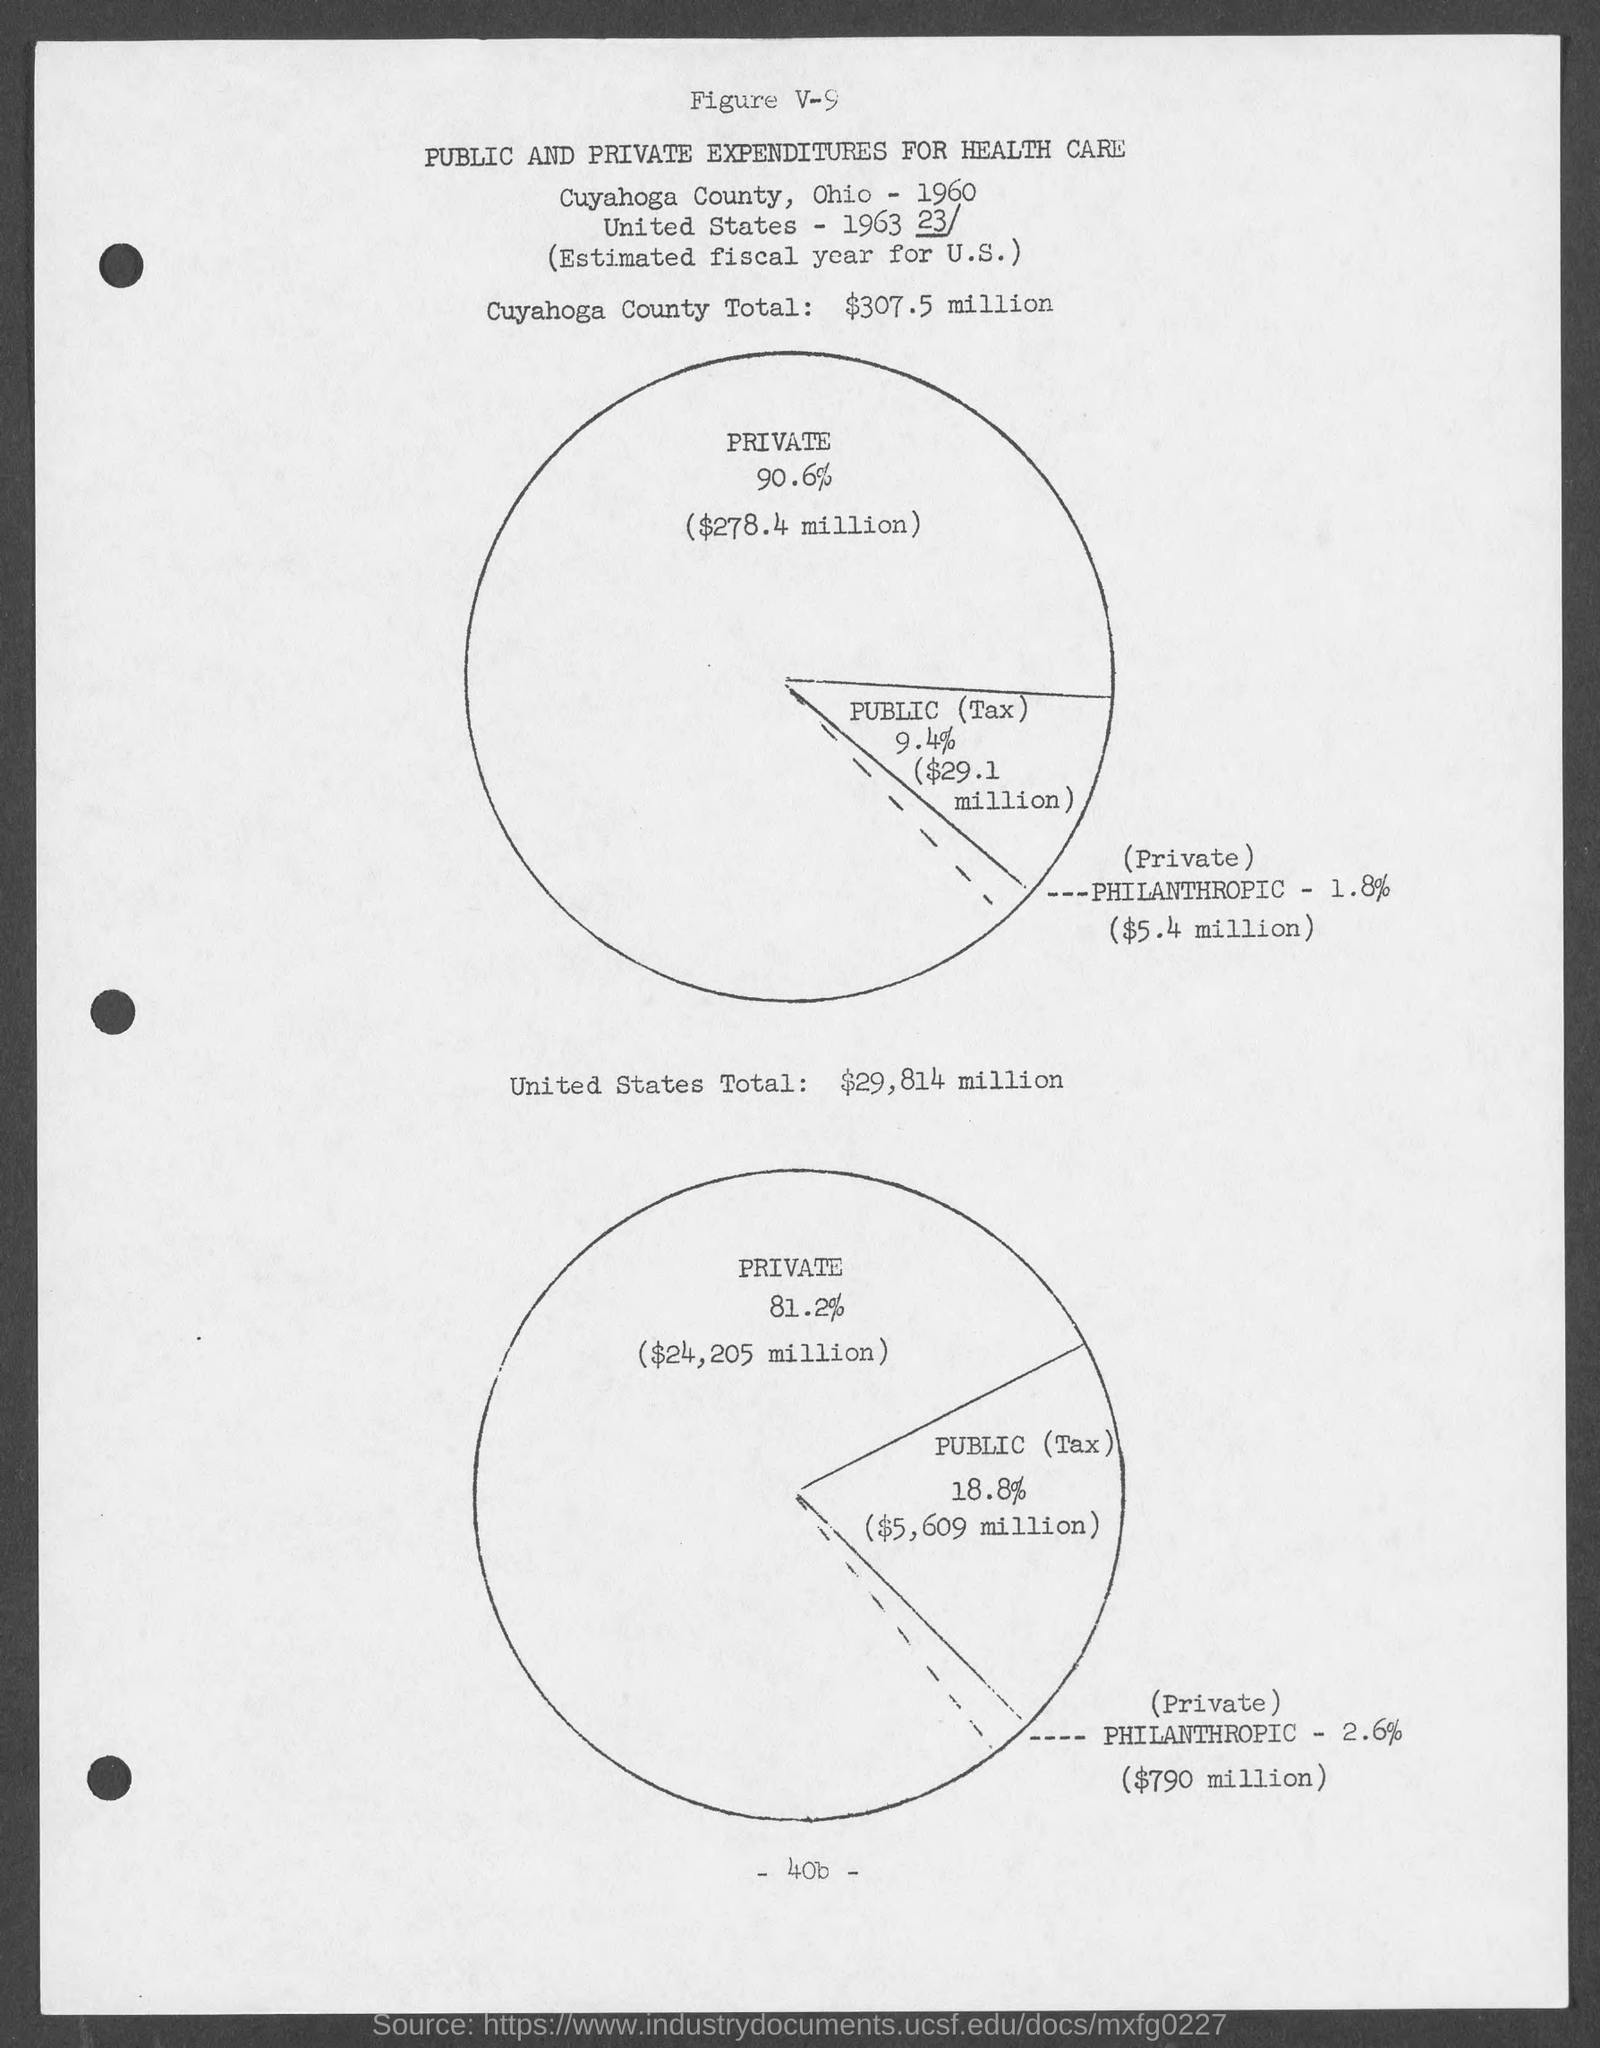What is the Cuyahoga County Total?
Your answer should be compact. $307.5 million. What is the United States Total?
Provide a short and direct response. $29,814 million. 